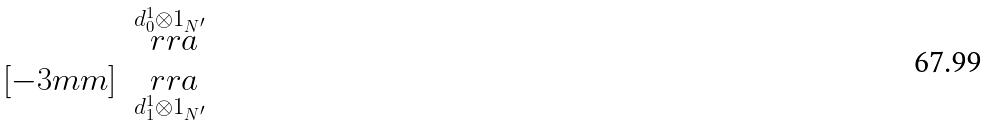<formula> <loc_0><loc_0><loc_500><loc_500>\begin{matrix} & \overset { d _ { 0 } ^ { 1 } \otimes 1 _ { N ^ { \prime } } } { \ r r a } \\ [ - 3 m m ] & \underset { d _ { 1 } ^ { 1 } \otimes 1 _ { N ^ { \prime } } } { \ r r a } \end{matrix}</formula> 